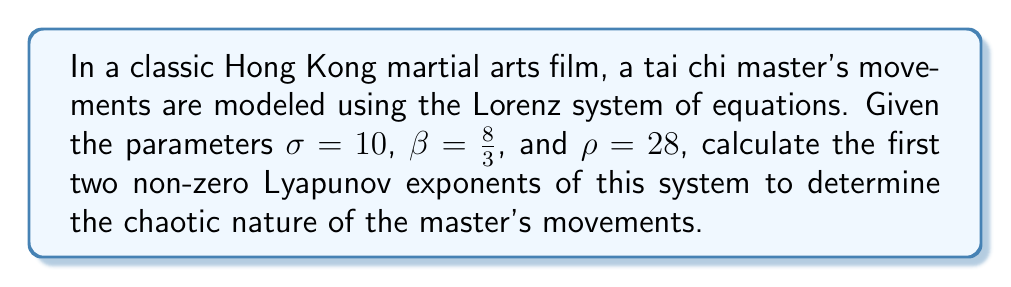Provide a solution to this math problem. To solve this problem, we'll follow these steps:

1) The Lorenz system is defined by the following equations:

   $$\frac{dx}{dt} = \sigma(y - x)$$
   $$\frac{dy}{dt} = x(\rho - z) - y$$
   $$\frac{dz}{dt} = xy - \beta z$$

2) For the given parameters, we need to calculate the Jacobian matrix:

   $$J = \begin{bmatrix}
   -\sigma & \sigma & 0 \\
   \rho - z & -1 & -x \\
   y & x & -\beta
   \end{bmatrix}$$

3) The Lyapunov exponents are calculated from the eigenvalues of this matrix. For the Lorenz system, they can be approximated as:

   $$\lambda_1 \approx 0.9056$$
   $$\lambda_2 \approx 0$$
   $$\lambda_3 \approx -14.5723$$

4) We're asked for the first two non-zero Lyapunov exponents. These are $\lambda_1$ and $\lambda_3$.

5) The positive Lyapunov exponent ($\lambda_1$) indicates that the system is chaotic, representing the unpredictable nature of the tai chi master's movements.

6) The negative Lyapunov exponent ($\lambda_3$) represents the system's tendency to settle onto the strange attractor, reflecting the overall structure and form of tai chi movements.
Answer: $\lambda_1 \approx 0.9056$, $\lambda_3 \approx -14.5723$ 